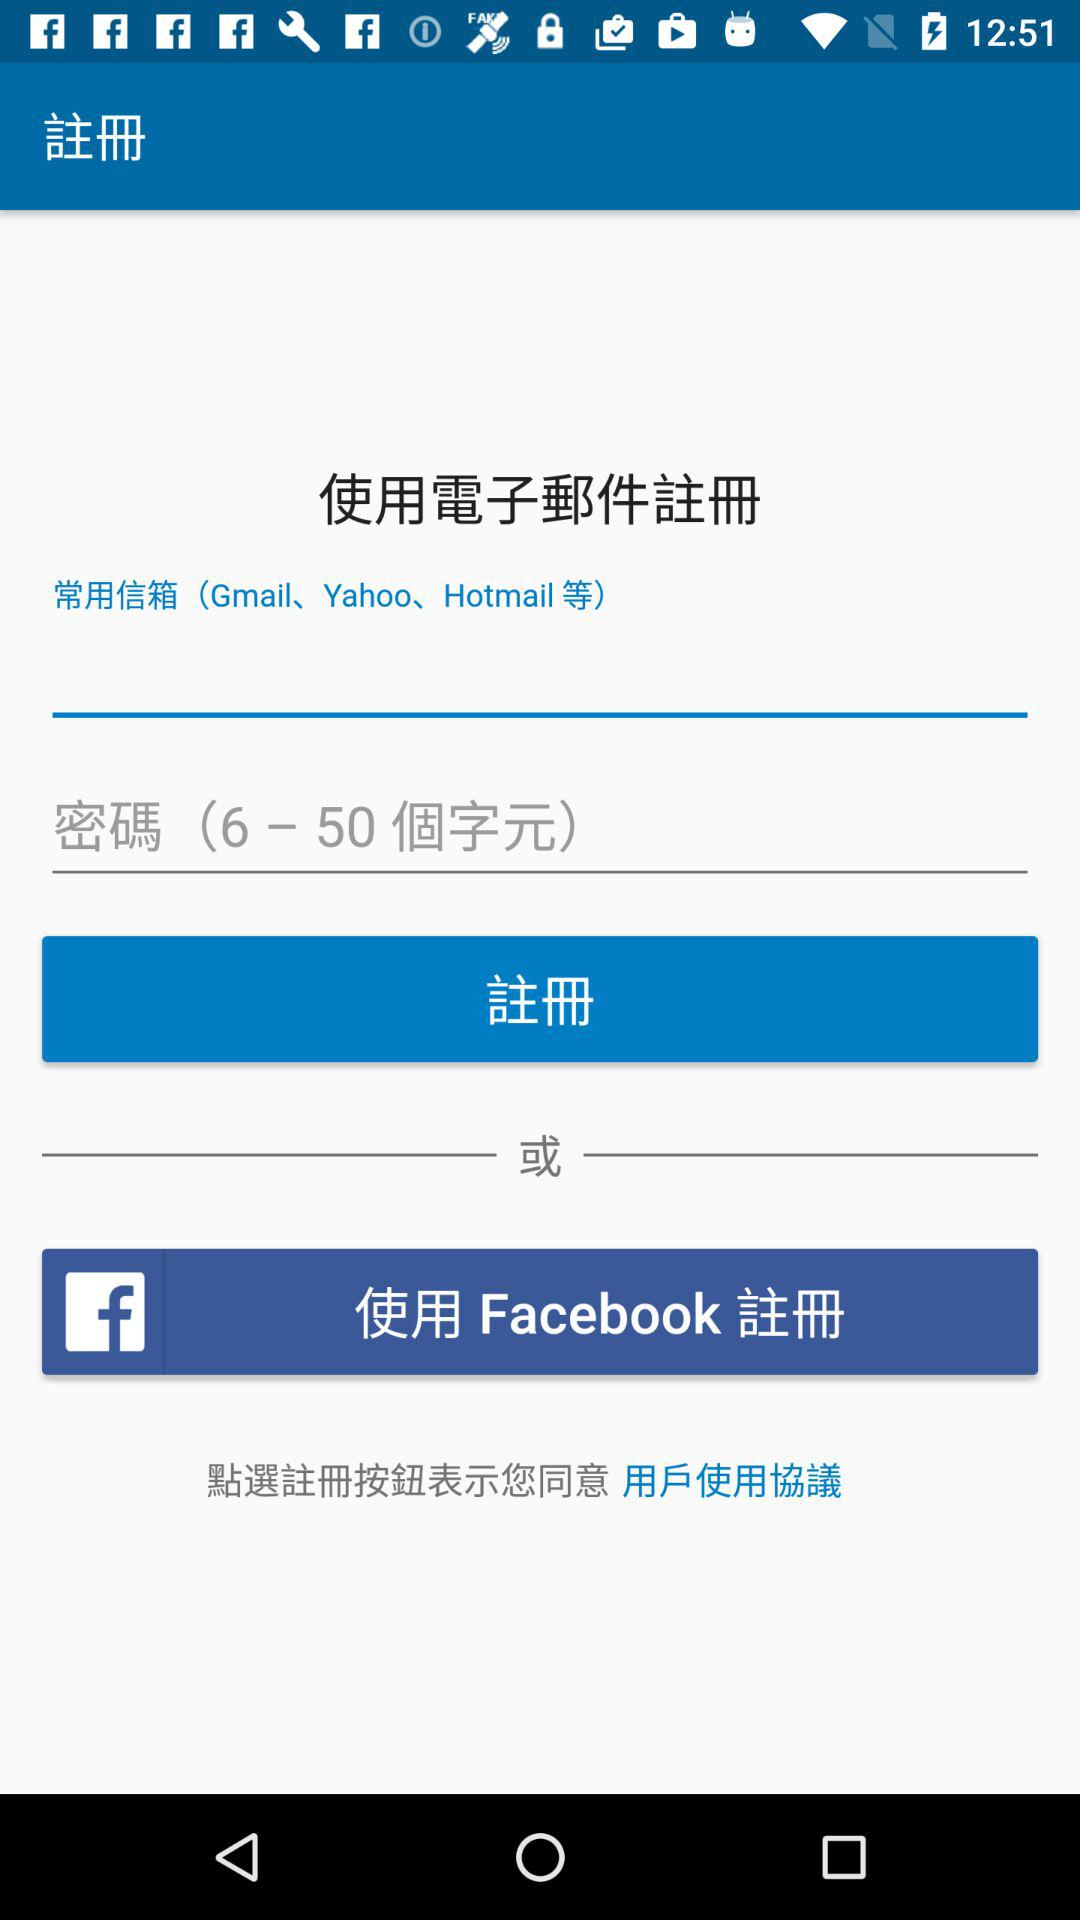How many text fields are there in the registration form?
Answer the question using a single word or phrase. 2 